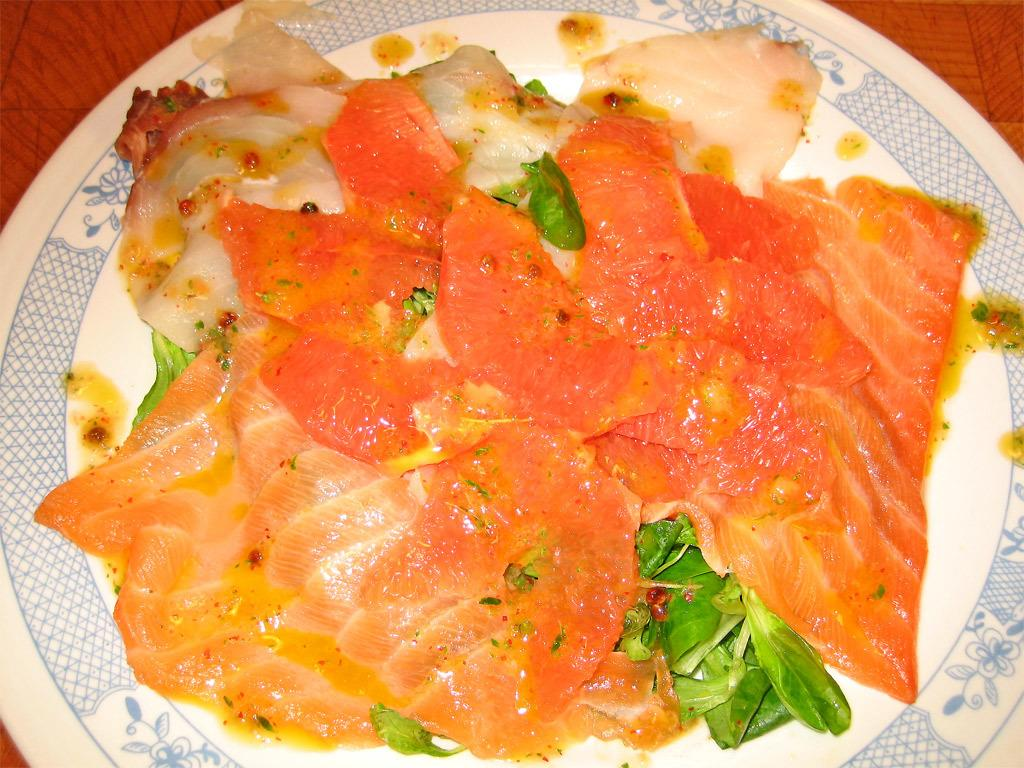What is located in the center of the image? There is a table in the center of the image. What is placed on the table? There is a plate on the table. What can be found on the plate? There are food items on the plate. How many quarters are visible on the plate in the image? There are no quarters present on the plate in the image. 